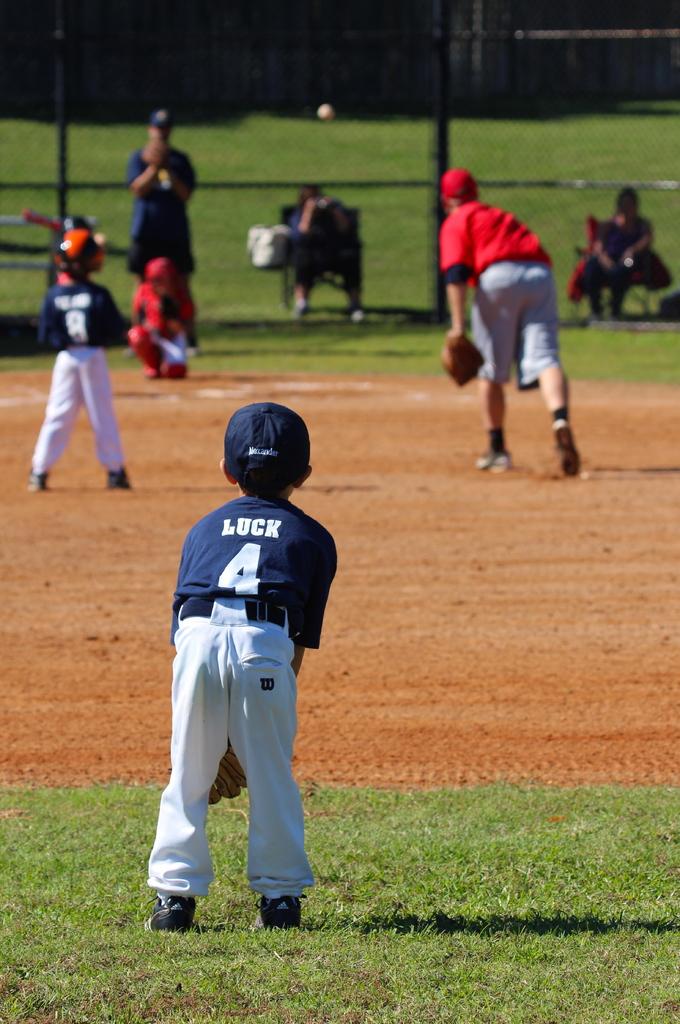What number is on the back of the boy's shirt?
Your answer should be very brief. 4. 